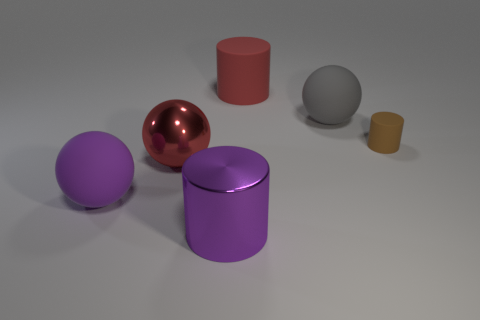Subtract all big matte spheres. How many spheres are left? 1 Add 3 big purple objects. How many objects exist? 9 Subtract all brown balls. Subtract all cyan cubes. How many balls are left? 3 Subtract all large red objects. Subtract all small things. How many objects are left? 3 Add 6 big shiny things. How many big shiny things are left? 8 Add 5 big red blocks. How many big red blocks exist? 5 Subtract 0 brown balls. How many objects are left? 6 